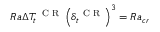Convert formula to latex. <formula><loc_0><loc_0><loc_500><loc_500>R a \Delta T _ { t } ^ { C R } \left ( \delta _ { t } ^ { C R } \right ) ^ { 3 } = R a _ { c r }</formula> 